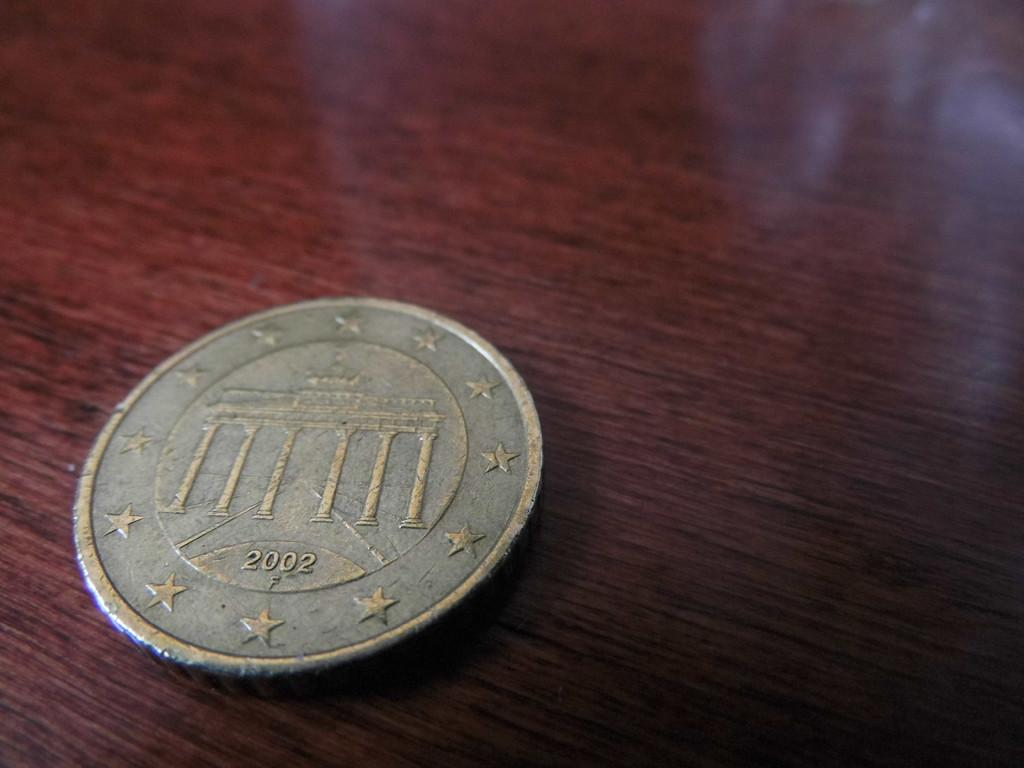<image>
Offer a succinct explanation of the picture presented. the year 2002 is written on the coin 